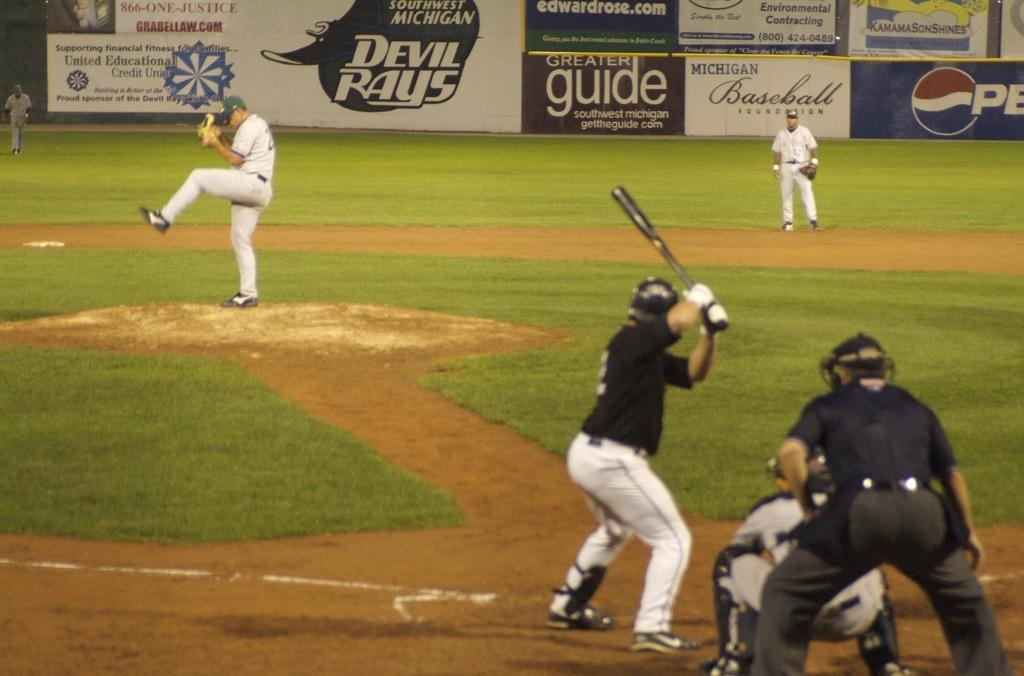<image>
Summarize the visual content of the image. The Michigan Devil Rays are playing baseball against an opposing team with a batter currently at the plate. 